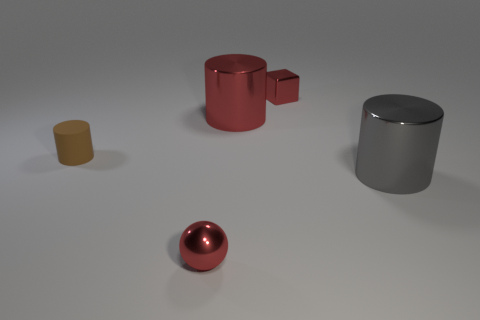Add 3 metal blocks. How many objects exist? 8 Subtract all cubes. How many objects are left? 4 Add 5 matte objects. How many matte objects are left? 6 Add 1 red rubber cubes. How many red rubber cubes exist? 1 Subtract 0 cyan cubes. How many objects are left? 5 Subtract all small red metallic objects. Subtract all large green cylinders. How many objects are left? 3 